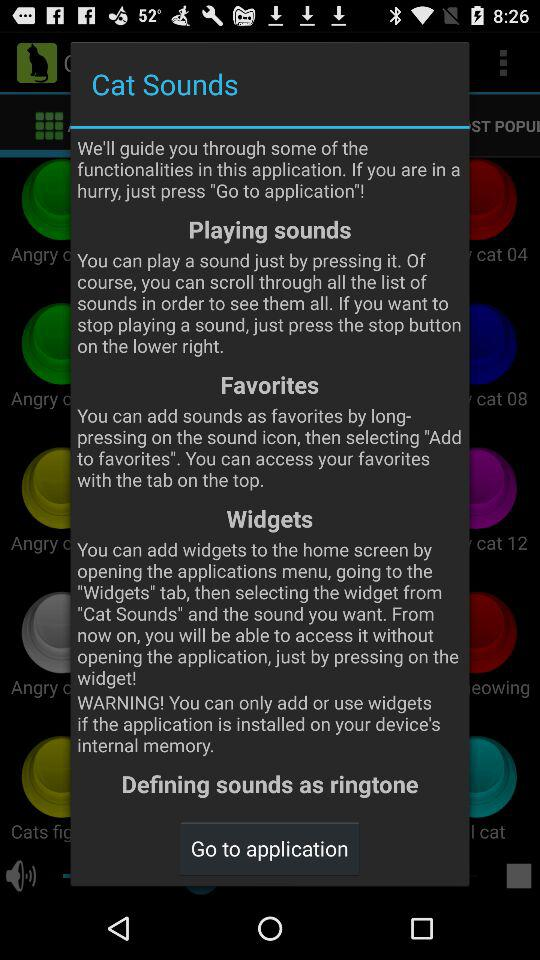How many tabs are available in this application?
Answer the question using a single word or phrase. 3 